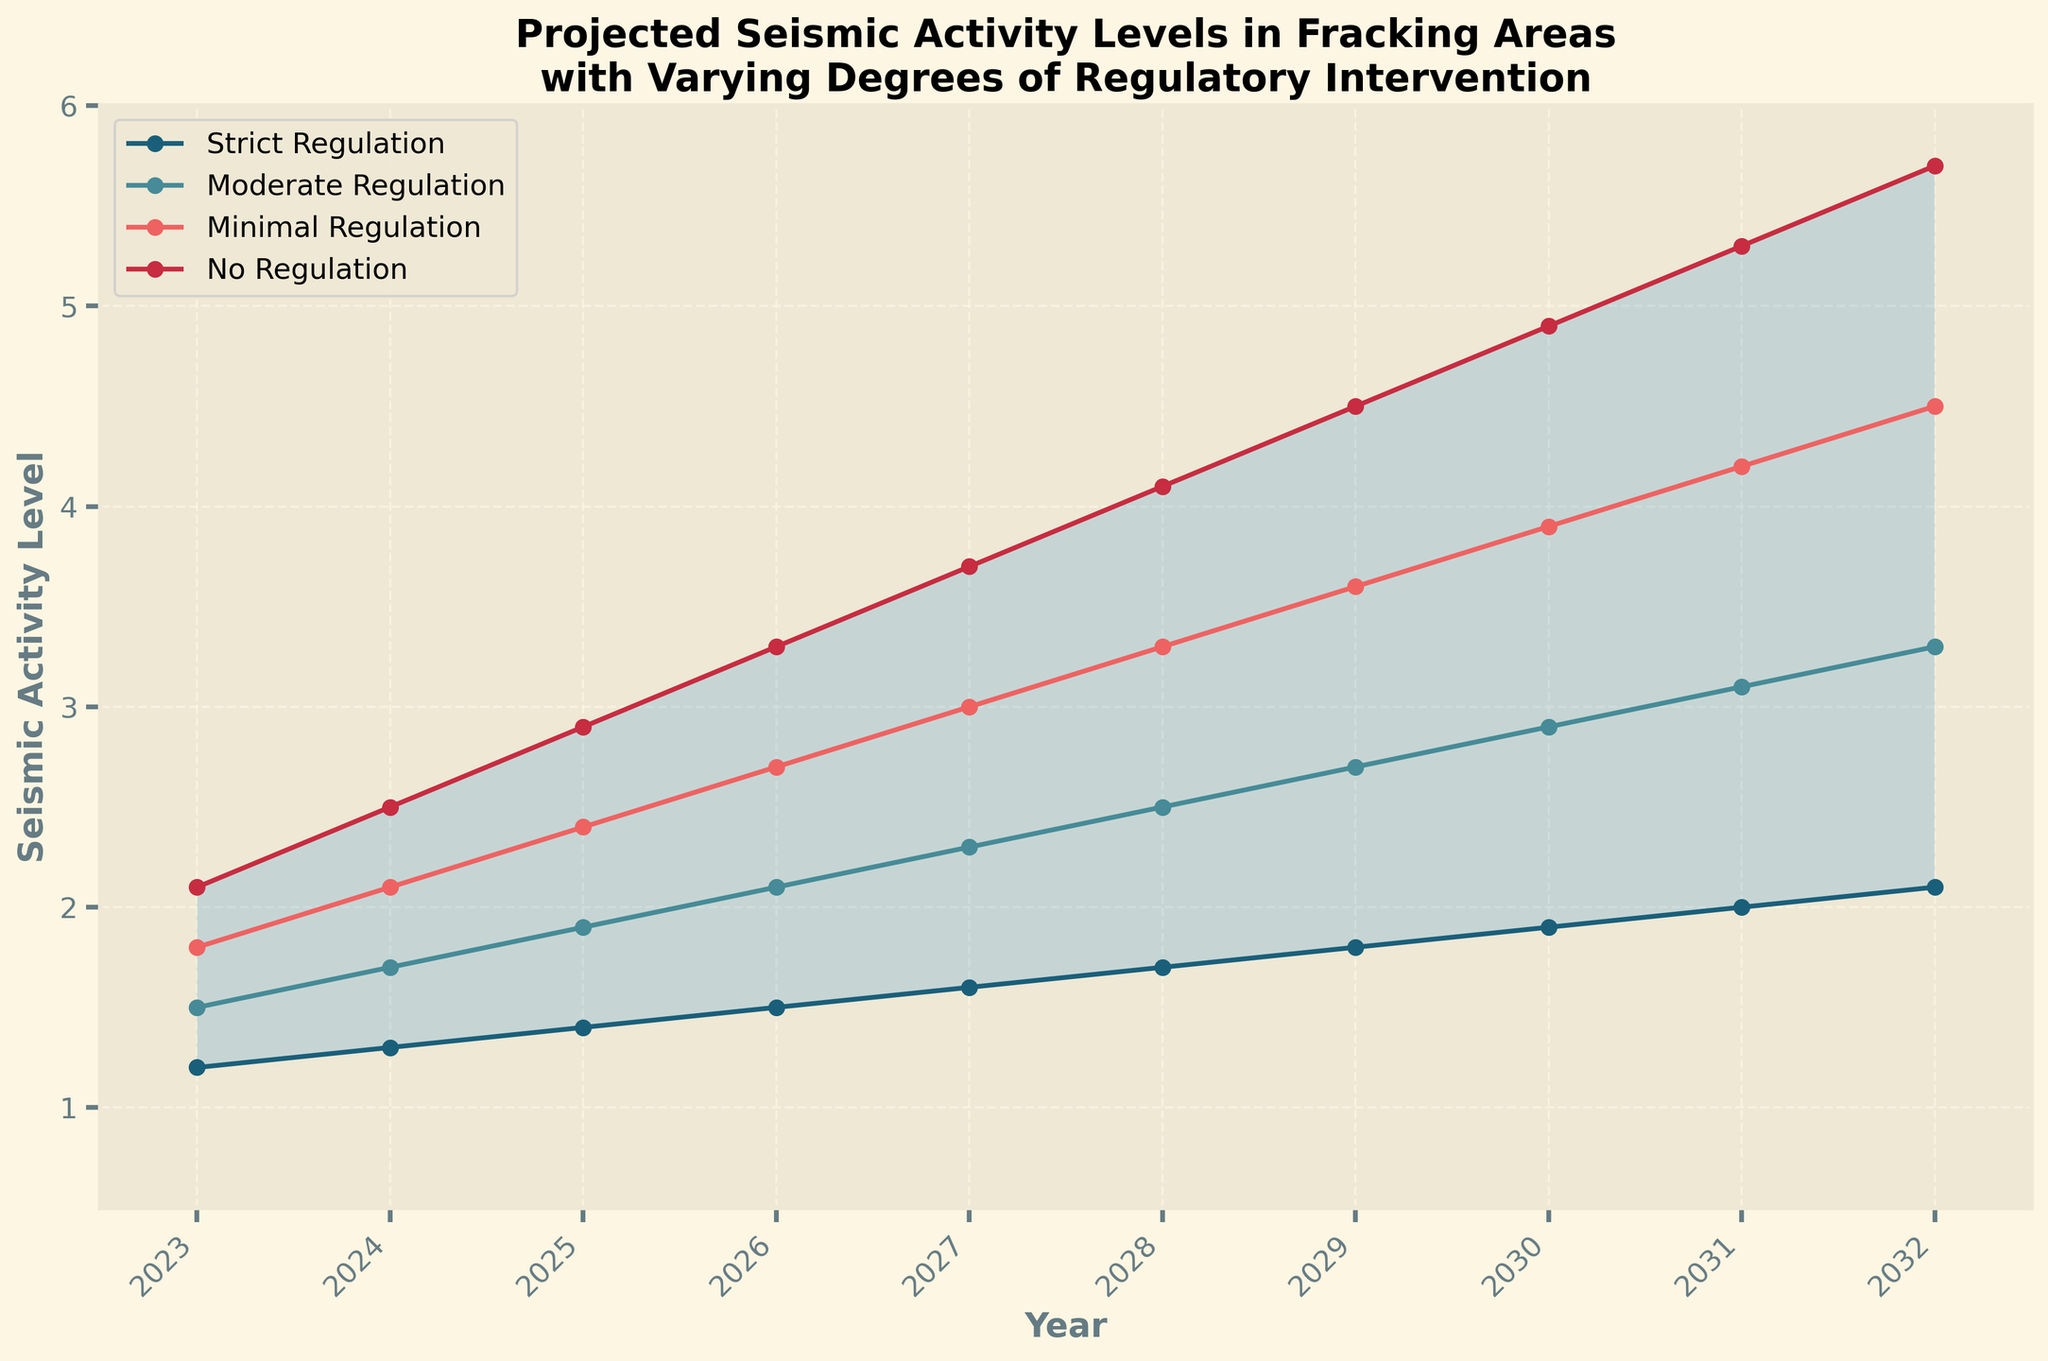What is the title of the chart? The title of the chart is clearly written at the top. It reads "Projected Seismic Activity Levels in Fracking Areas with Varying Degrees of Regulatory Intervention."
Answer: Projected Seismic Activity Levels in Fracking Areas with Varying Degrees of Regulatory Intervention How many scenario lines are plotted in the chart? The chart shows lines for each of the four scenarios: 'Strict Regulation,' 'Moderate Regulation,' 'Minimal Regulation,' and 'No Regulation,' as labeled by the legend.
Answer: Four Which regulatory scenario shows the highest projected seismic activity in 2026? By examining the 2026 data points, we see that the 'No Regulation' line is the highest on the vertical axis at that year.
Answer: No Regulation What is the projected seismic activity level for 'Strict Regulation' in 2029? Locate the 'Strict Regulation' line and follow it to the year 2029; the corresponding value on the y-axis is 1.8.
Answer: 1.8 Between which years does the range of seismic activity levels become largest? The range is indicated by the shaded area between the 'Strict Regulation' and 'No Regulation' lines. It appears widest between 2028 and 2032.
Answer: 2028 and 2032 How does the seismic activity level change for 'Moderate Regulation' from 2023 to 2024? For 'Moderate Regulation,' the level increases from 1.5 in 2023 to 1.7 in 2024, indicating an increase.
Answer: Increase By how much is the projected seismic activity level under 'Minimal Regulation' higher in 2032 compared to 2027? The 'Minimal Regulation' level is 4.5 in 2032 and 3.0 in 2027. The difference is 4.5 - 3.0.
Answer: 1.5 What is the average projected seismic activity level for 'No Regulation' over the period 2023-2032? Sum the 'No Regulation' values from 2023 to 2032 and divide by the number of years (10): (2.1 + 2.5 + 2.9 + 3.3 + 3.7 + 4.1 + 4.5 + 4.9 + 5.3 + 5.7) / 10 = 39/10.
Answer: 3.9 Which regulatory scenario has the steepest increase in seismic activity between 2026 and 2027? Compare the slopes of each line between 2026 and 2027; the 'No Regulation' line shows the largest vertical increase, going from 3.3 to 3.7.
Answer: No Regulation What is the general trend observed in seismic activity levels for all regulatory scenarios over the decade? All lines representing different regulatory scenarios show an upward trend, indicating increasing seismic activity levels over the next decade.
Answer: Increasing 